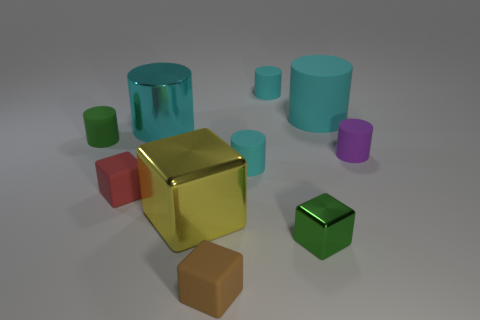Subtract all small cyan matte cylinders. How many cylinders are left? 4 Subtract all cubes. How many objects are left? 6 Subtract all green blocks. How many blocks are left? 3 Subtract 2 cylinders. How many cylinders are left? 4 Subtract all blue cylinders. Subtract all brown spheres. How many cylinders are left? 6 Subtract all red cylinders. How many red cubes are left? 1 Subtract all small red matte things. Subtract all small cyan cylinders. How many objects are left? 7 Add 8 metallic cylinders. How many metallic cylinders are left? 9 Add 8 big purple spheres. How many big purple spheres exist? 8 Subtract 0 purple cubes. How many objects are left? 10 